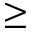<formula> <loc_0><loc_0><loc_500><loc_500>\geq</formula> 